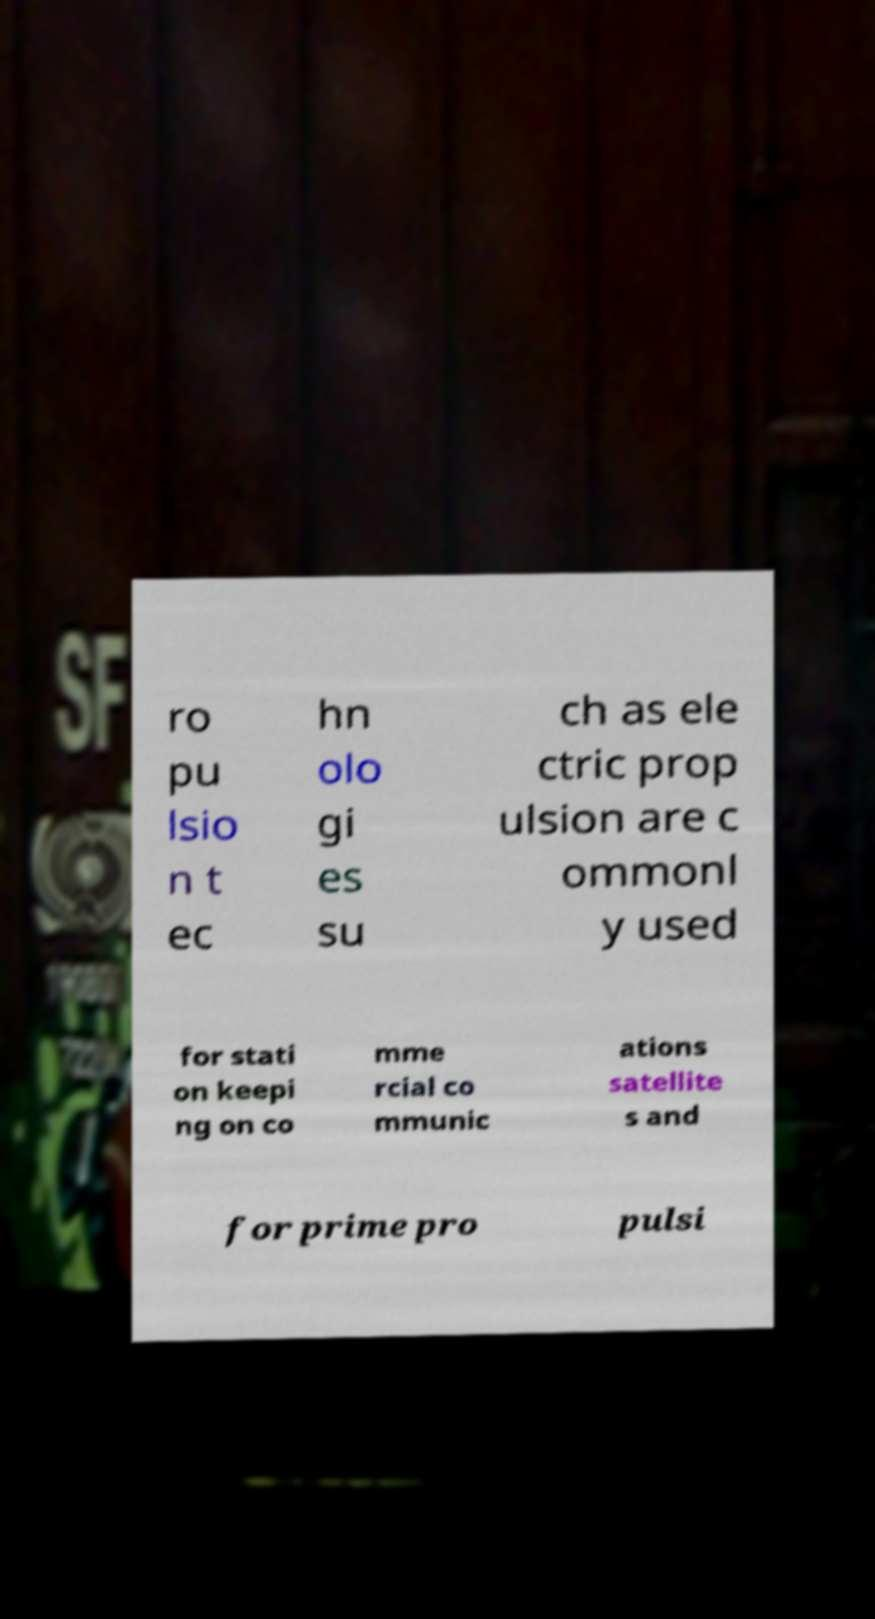There's text embedded in this image that I need extracted. Can you transcribe it verbatim? ro pu lsio n t ec hn olo gi es su ch as ele ctric prop ulsion are c ommonl y used for stati on keepi ng on co mme rcial co mmunic ations satellite s and for prime pro pulsi 